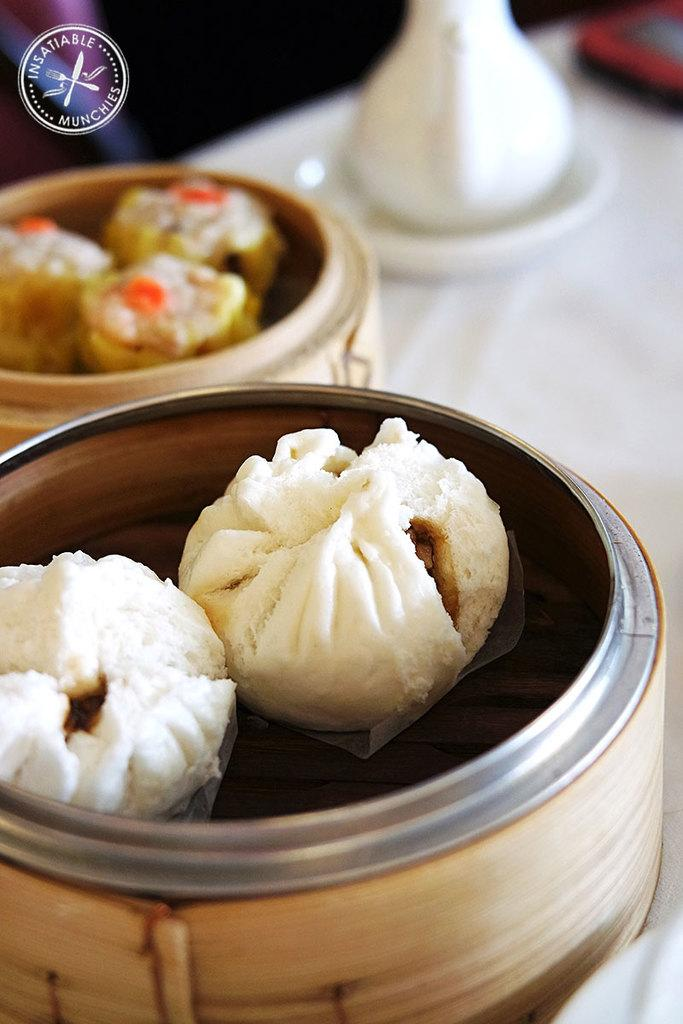<image>
Offer a succinct explanation of the picture presented. A picture of desserts from the Insatiable Munchies company. 